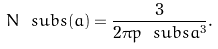<formula> <loc_0><loc_0><loc_500><loc_500>N \ s u b { s } ( a ) = \frac { 3 } { 2 \pi p \ s u b { s } a ^ { 3 } } .</formula> 